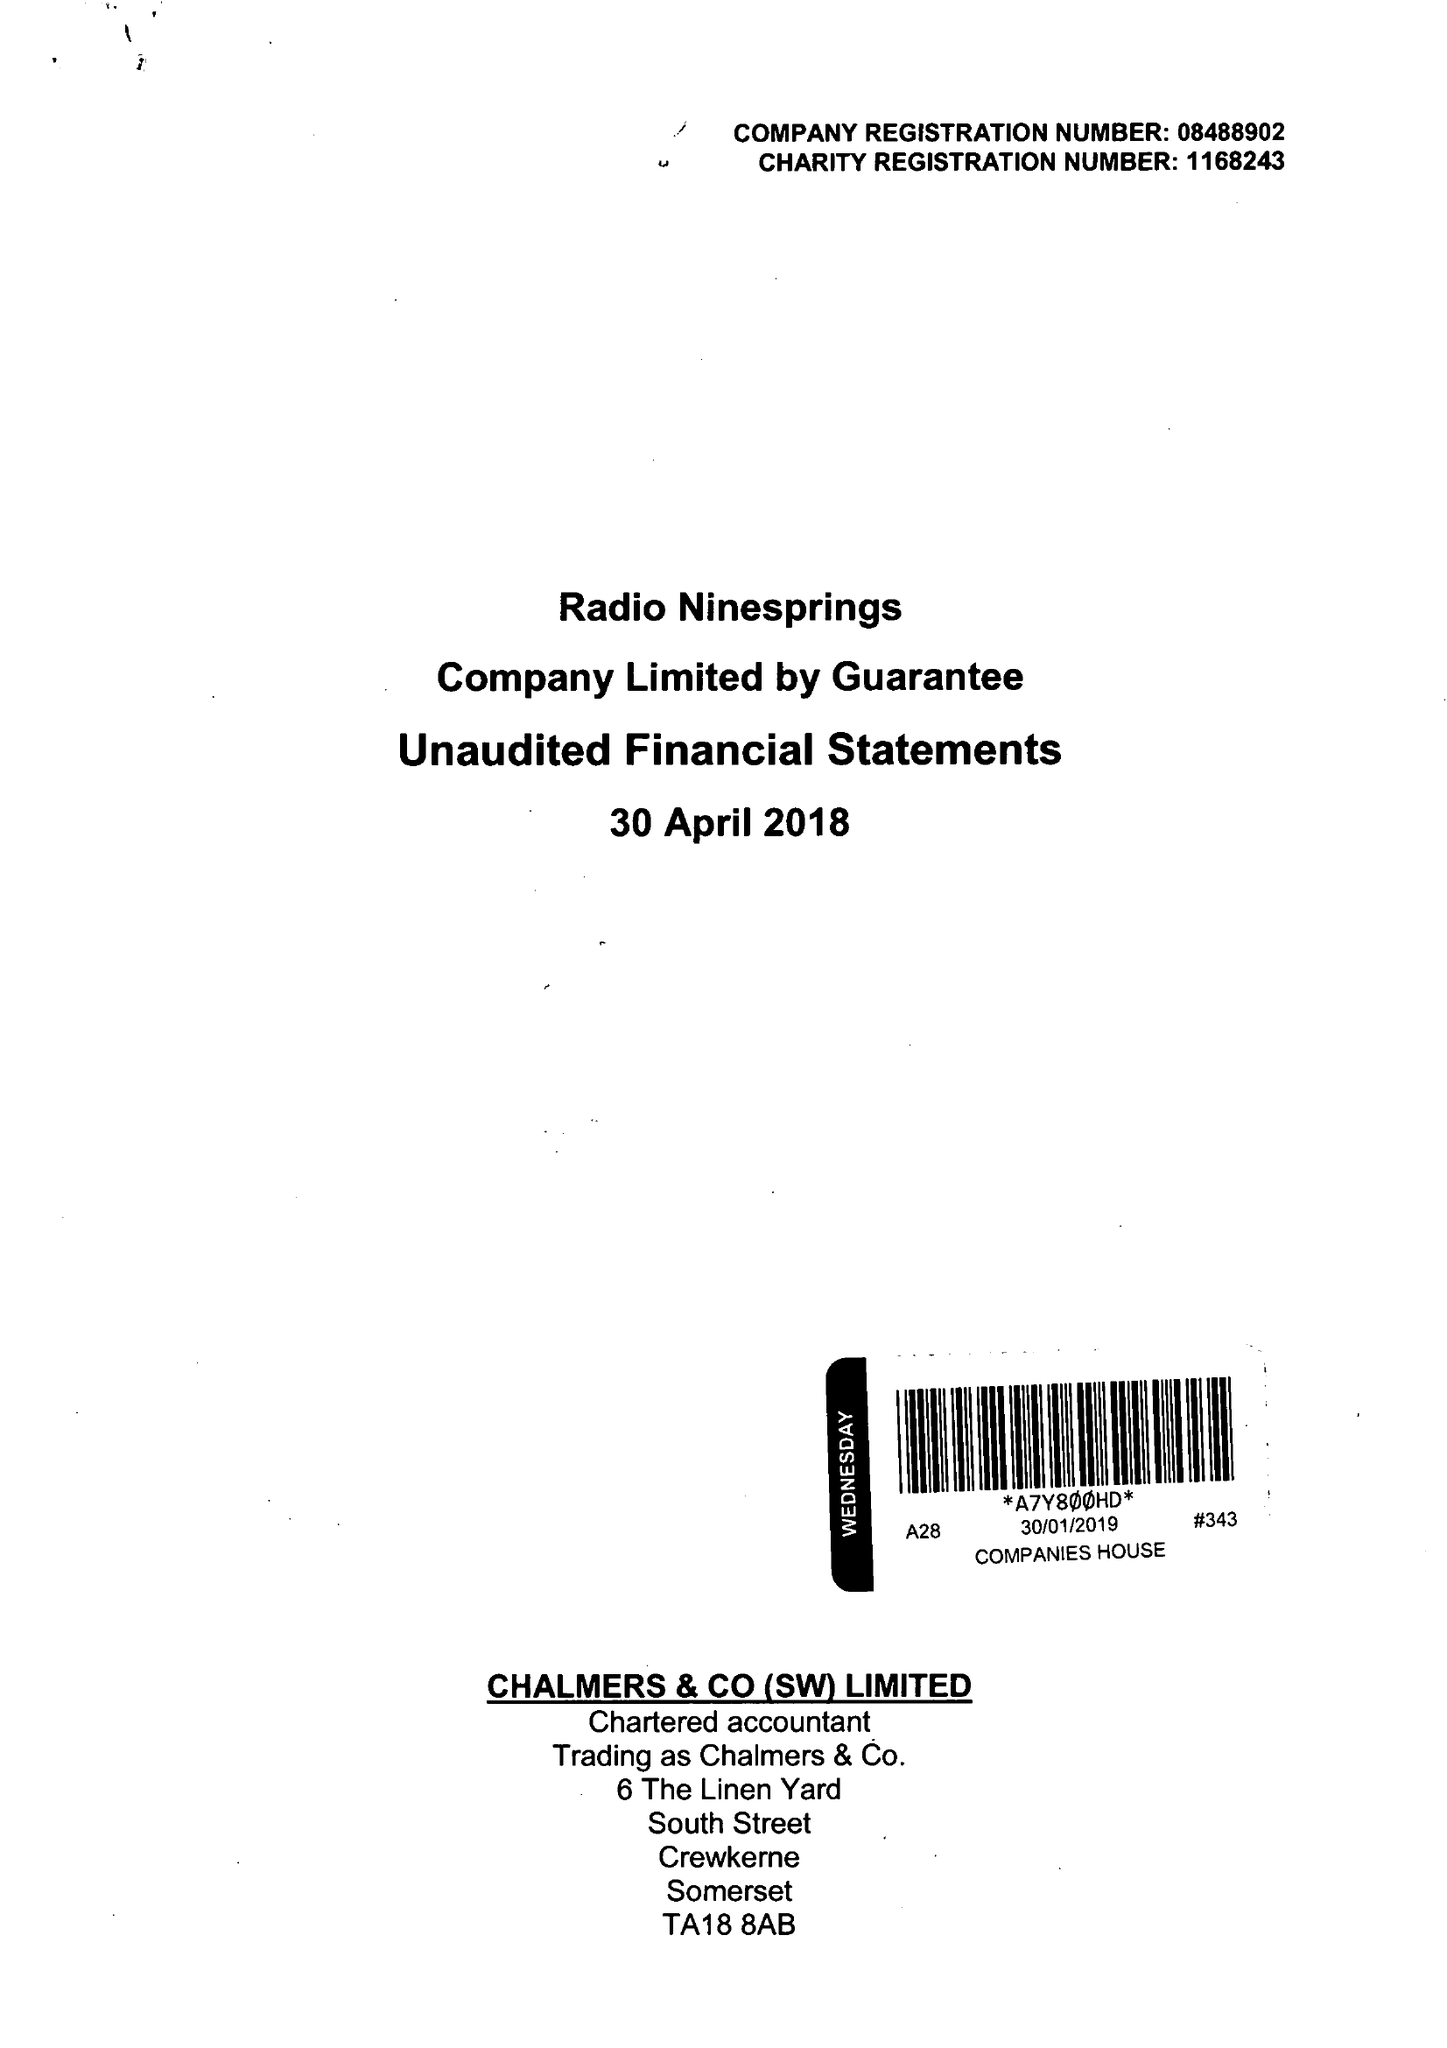What is the value for the address__post_town?
Answer the question using a single word or phrase. YEOVIL 